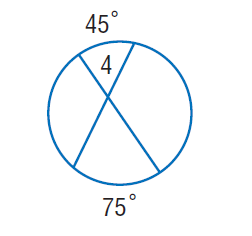Question: Find \angle 4.
Choices:
A. 45
B. 60
C. 75
D. 120
Answer with the letter. Answer: B 